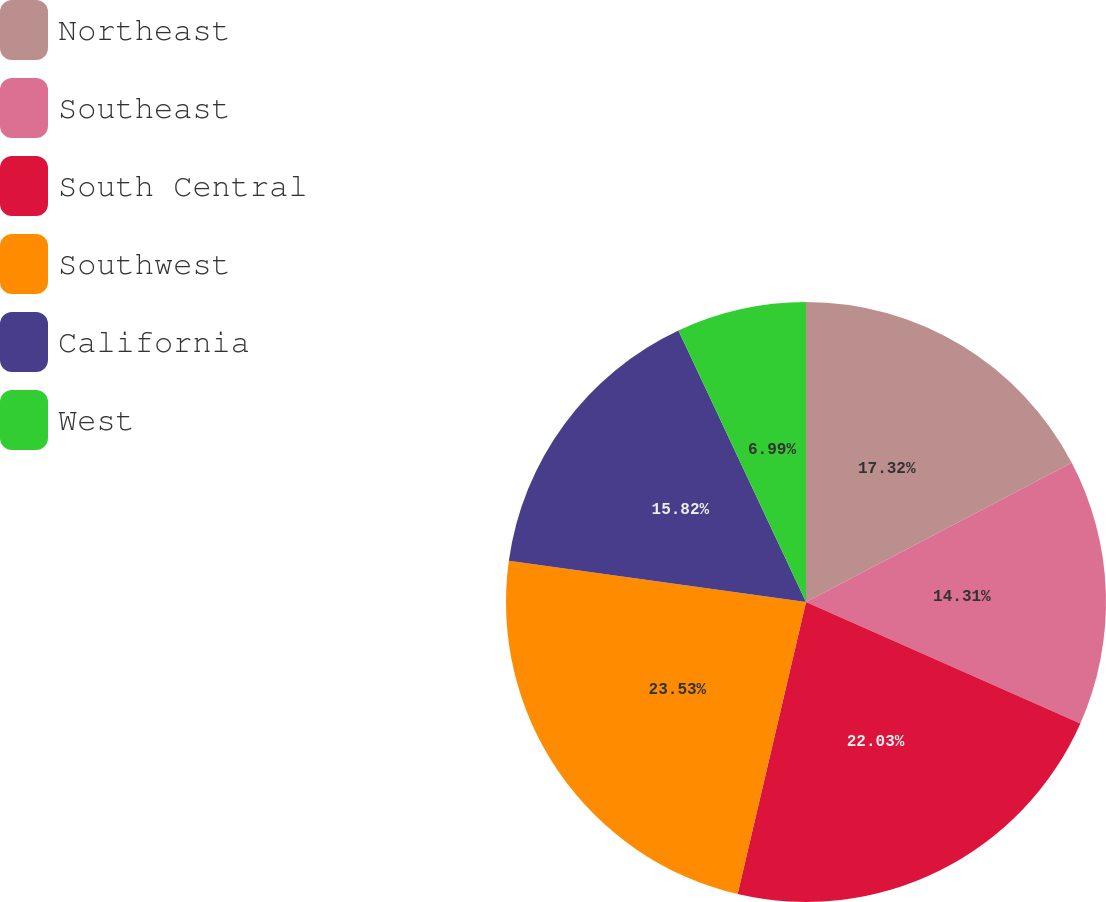Convert chart. <chart><loc_0><loc_0><loc_500><loc_500><pie_chart><fcel>Northeast<fcel>Southeast<fcel>South Central<fcel>Southwest<fcel>California<fcel>West<nl><fcel>17.32%<fcel>14.31%<fcel>22.03%<fcel>23.53%<fcel>15.82%<fcel>6.99%<nl></chart> 